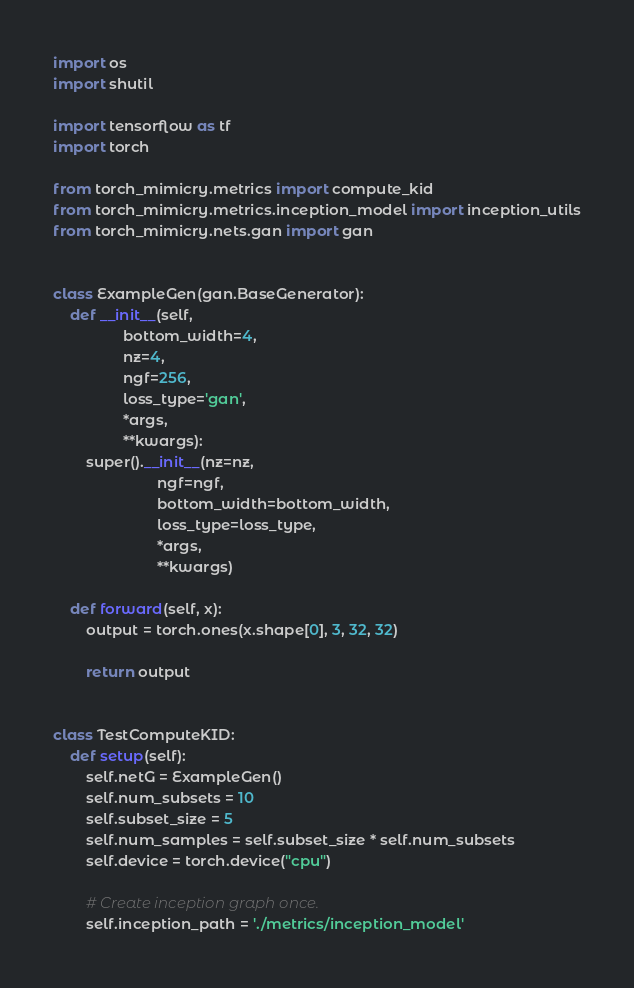<code> <loc_0><loc_0><loc_500><loc_500><_Python_>import os
import shutil

import tensorflow as tf
import torch

from torch_mimicry.metrics import compute_kid
from torch_mimicry.metrics.inception_model import inception_utils
from torch_mimicry.nets.gan import gan


class ExampleGen(gan.BaseGenerator):
    def __init__(self,
                 bottom_width=4,
                 nz=4,
                 ngf=256,
                 loss_type='gan',
                 *args,
                 **kwargs):
        super().__init__(nz=nz,
                         ngf=ngf,
                         bottom_width=bottom_width,
                         loss_type=loss_type,
                         *args,
                         **kwargs)

    def forward(self, x):
        output = torch.ones(x.shape[0], 3, 32, 32)

        return output


class TestComputeKID:
    def setup(self):
        self.netG = ExampleGen()
        self.num_subsets = 10
        self.subset_size = 5
        self.num_samples = self.subset_size * self.num_subsets
        self.device = torch.device("cpu")

        # Create inception graph once.
        self.inception_path = './metrics/inception_model'
</code> 